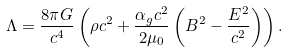<formula> <loc_0><loc_0><loc_500><loc_500>\Lambda = \frac { 8 \pi G } { c ^ { 4 } } \left ( \rho { c } ^ { 2 } + \frac { \alpha _ { g } c ^ { 2 } } { 2 \mu _ { 0 } } \left ( B ^ { 2 } - \frac { E ^ { 2 } } { c ^ { 2 } } \right ) \right ) .</formula> 